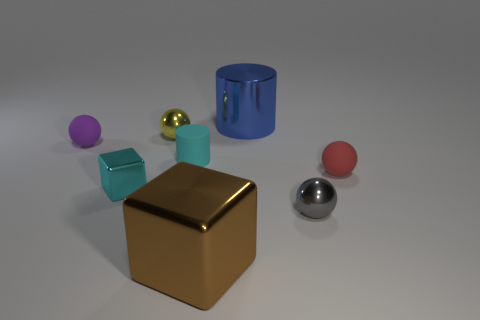Add 1 tiny red spheres. How many objects exist? 9 Subtract all cylinders. How many objects are left? 6 Subtract all small cyan things. Subtract all tiny cyan matte cylinders. How many objects are left? 5 Add 7 gray metallic objects. How many gray metallic objects are left? 8 Add 1 purple matte balls. How many purple matte balls exist? 2 Subtract 1 gray balls. How many objects are left? 7 